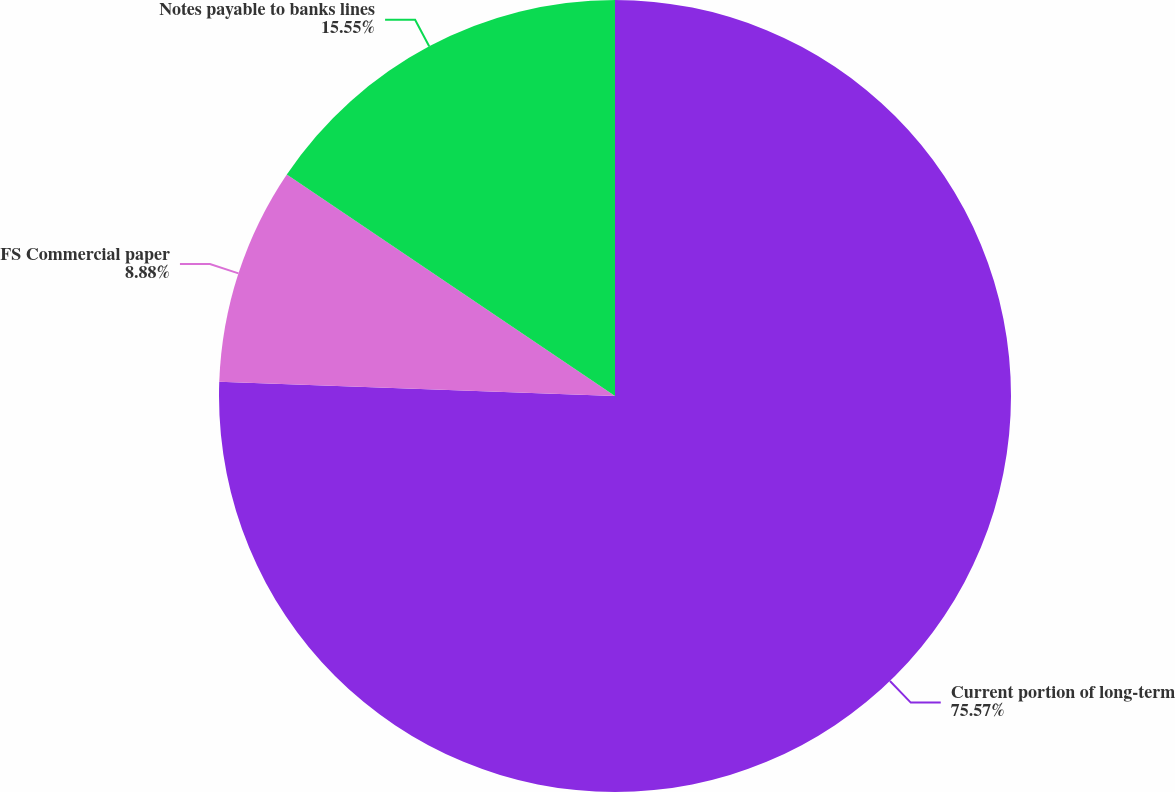Convert chart. <chart><loc_0><loc_0><loc_500><loc_500><pie_chart><fcel>Current portion of long-term<fcel>FS Commercial paper<fcel>Notes payable to banks lines<nl><fcel>75.58%<fcel>8.88%<fcel>15.55%<nl></chart> 